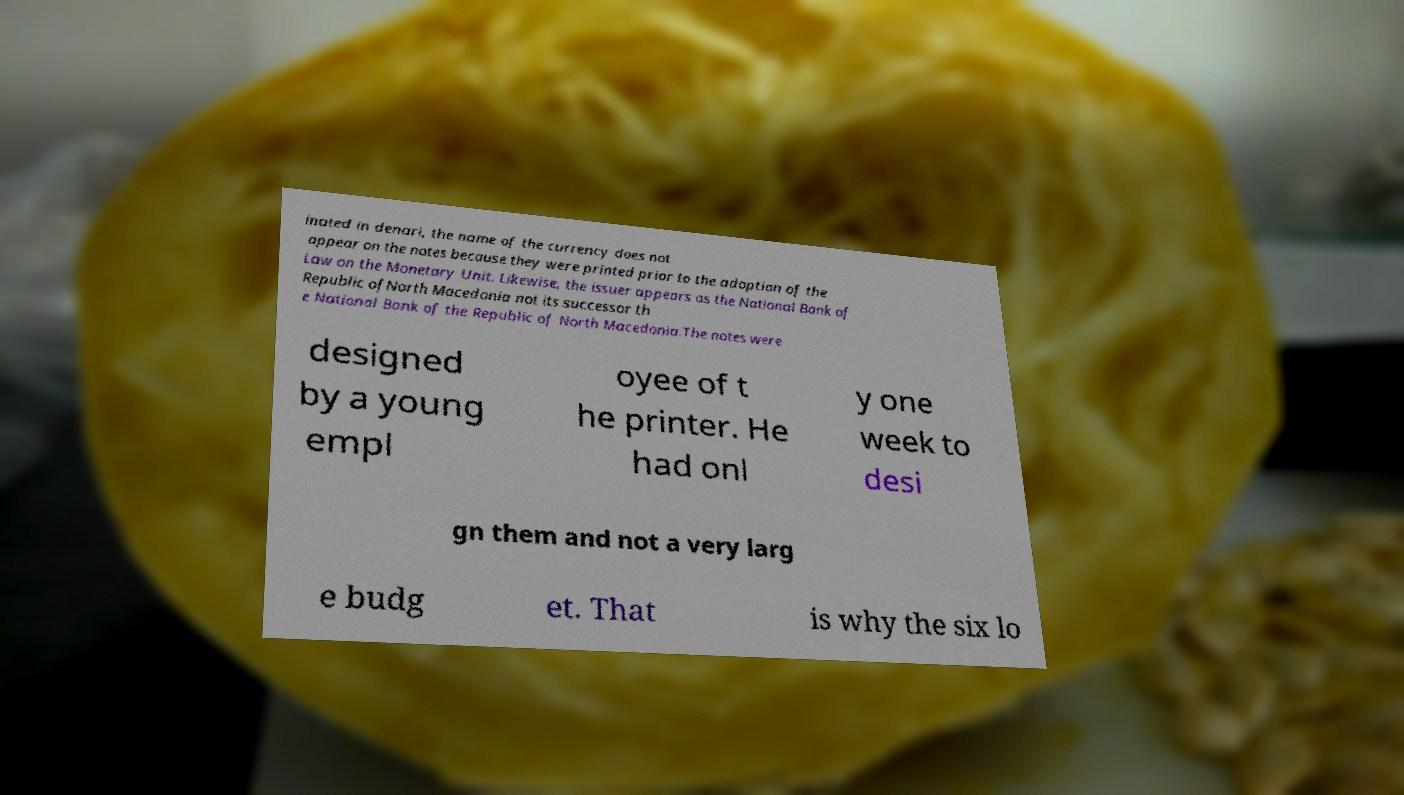Could you assist in decoding the text presented in this image and type it out clearly? inated in denari, the name of the currency does not appear on the notes because they were printed prior to the adoption of the Law on the Monetary Unit. Likewise, the issuer appears as the National Bank of Republic ofNorth Macedonia not its successor th e National Bank of the Republic of North Macedonia.The notes were designed by a young empl oyee of t he printer. He had onl y one week to desi gn them and not a very larg e budg et. That is why the six lo 